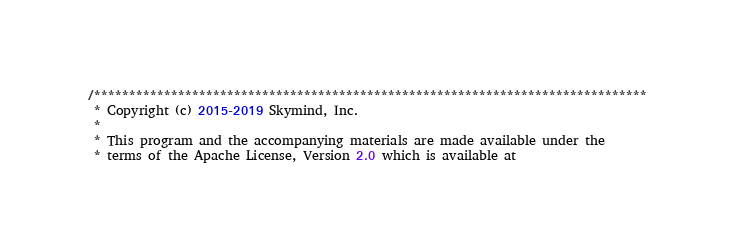<code> <loc_0><loc_0><loc_500><loc_500><_Java_>/*******************************************************************************
 * Copyright (c) 2015-2019 Skymind, Inc.
 *
 * This program and the accompanying materials are made available under the
 * terms of the Apache License, Version 2.0 which is available at</code> 